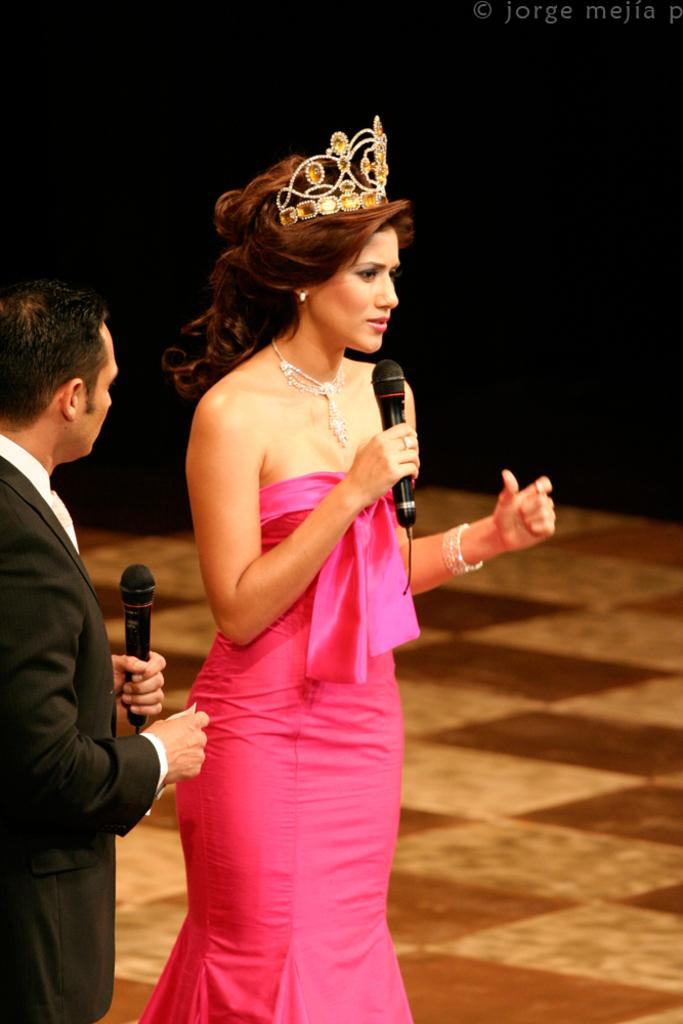Who are the people in the image? There is a man and a woman in the image. What are the man and the woman holding? Both the man and the woman are holding microphones. What can be observed about the background of the image? The background of the image is dark. Is there any text visible in the image? Yes, there is some text in the top right-hand corner of the image. How many rings are visible on the man's fingers in the image? There are no rings visible on the man's fingers in the image. What is the man learning from the woman in the image? There is no indication in the image that the man is learning from the woman, as they are both holding microphones and there is no context provided for their interaction. 